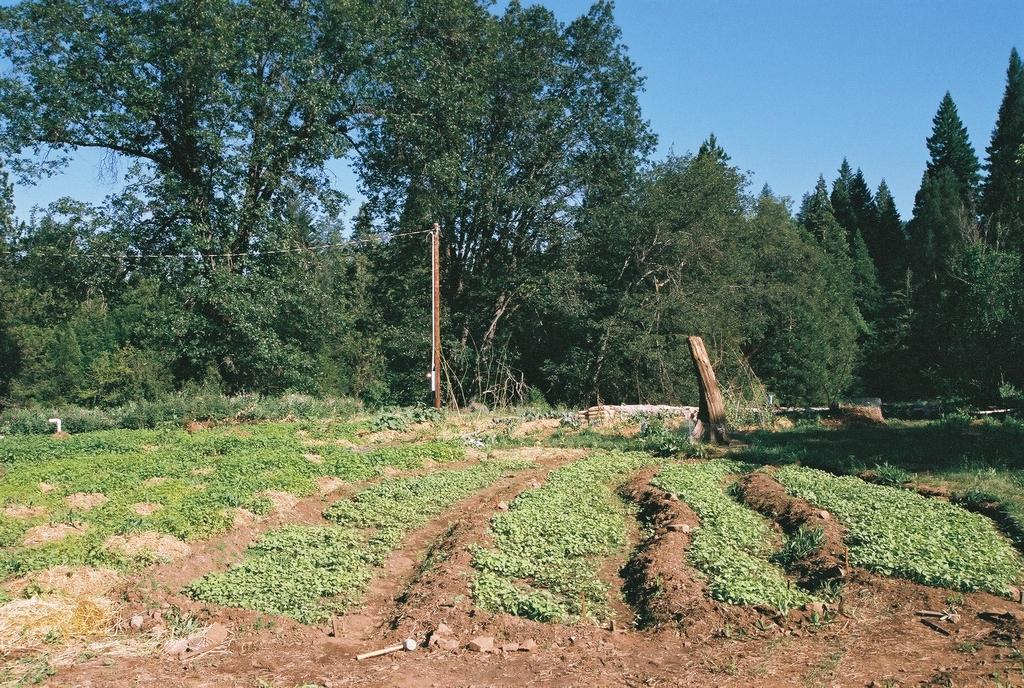What type of vegetation is present in the image? There is grass in the image. What can be seen in the background of the image? There are groups of trees in the background of the image. What type of minister is present in the image? There is no minister present in the image; it features grass and trees. Where is the coach located in the image? There is no coach present in the image; it features grass and trees. 